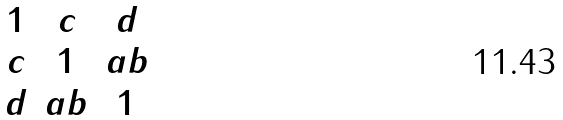<formula> <loc_0><loc_0><loc_500><loc_500>\begin{matrix} 1 & c & d \\ c & 1 & a b \\ d & a b & 1 \end{matrix}</formula> 